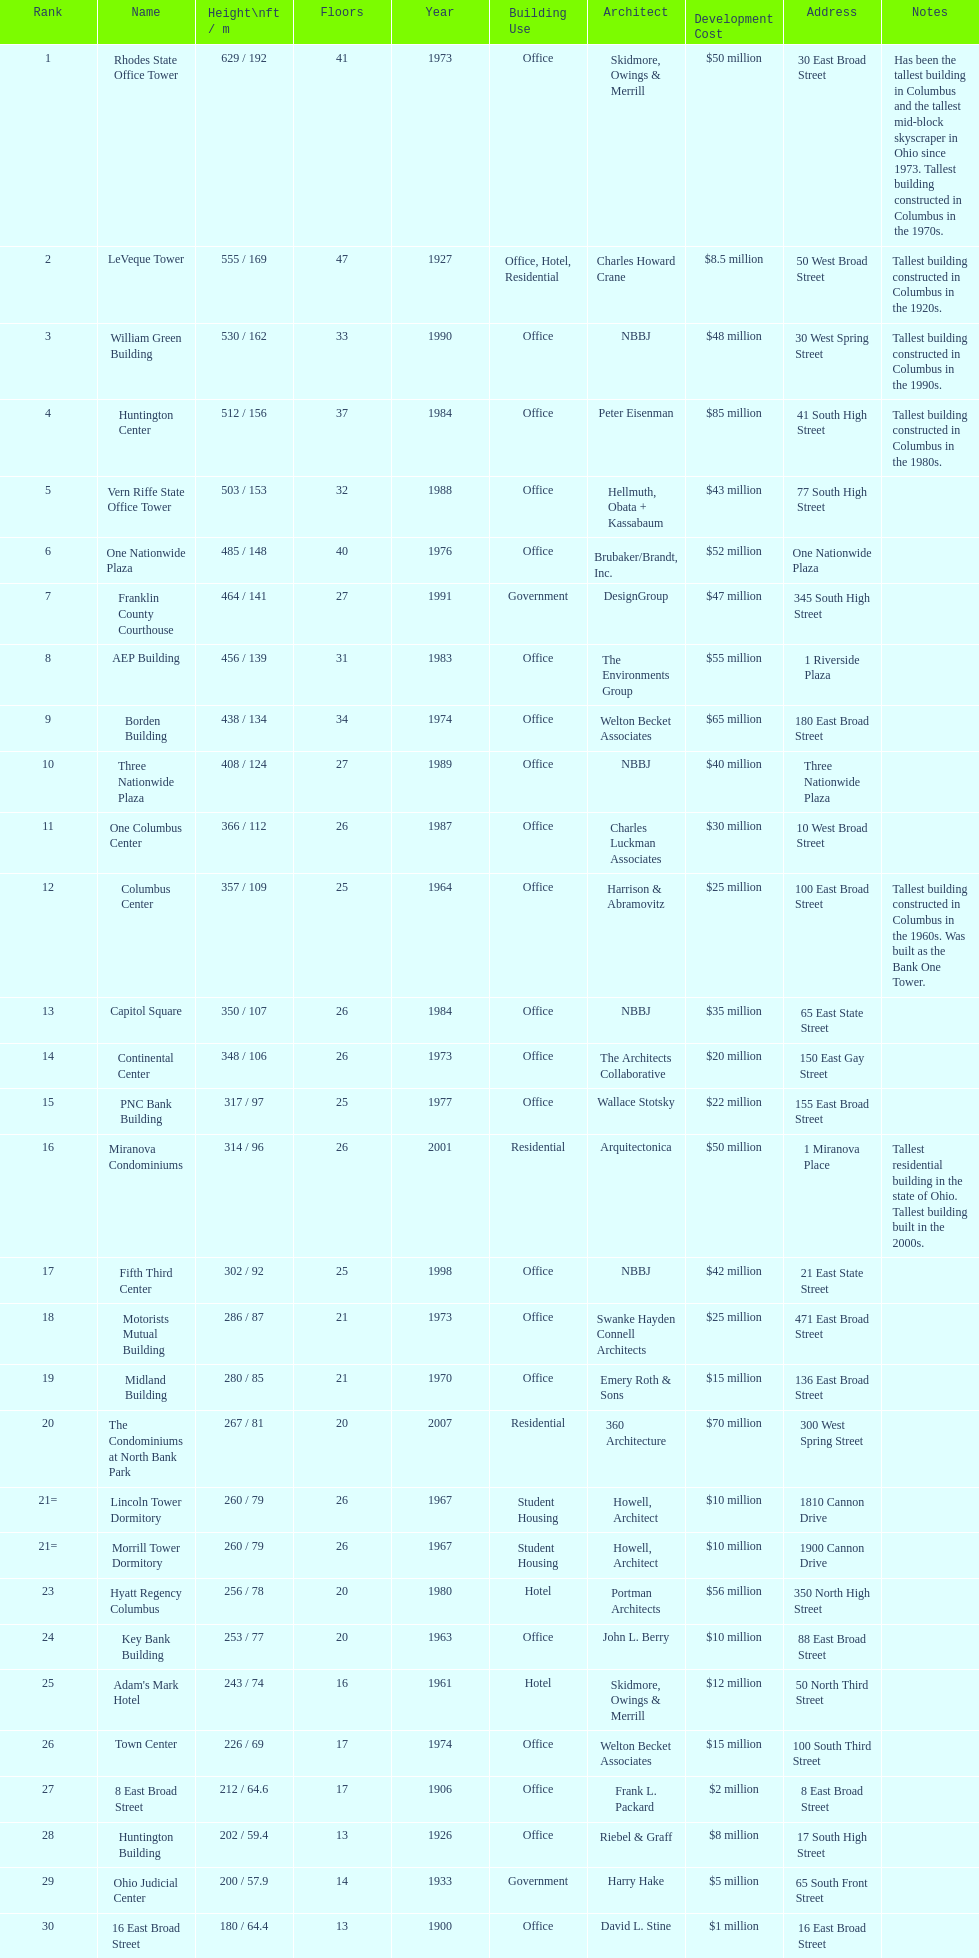Which buildings are taller than 500 ft? Rhodes State Office Tower, LeVeque Tower, William Green Building, Huntington Center, Vern Riffe State Office Tower. 